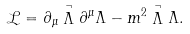Convert formula to latex. <formula><loc_0><loc_0><loc_500><loc_500>\mathcal { L } = \partial _ { \mu } \stackrel { \neg } \Lambda \partial ^ { \mu } \Lambda - m ^ { 2 } \stackrel { \neg } \Lambda \Lambda .</formula> 